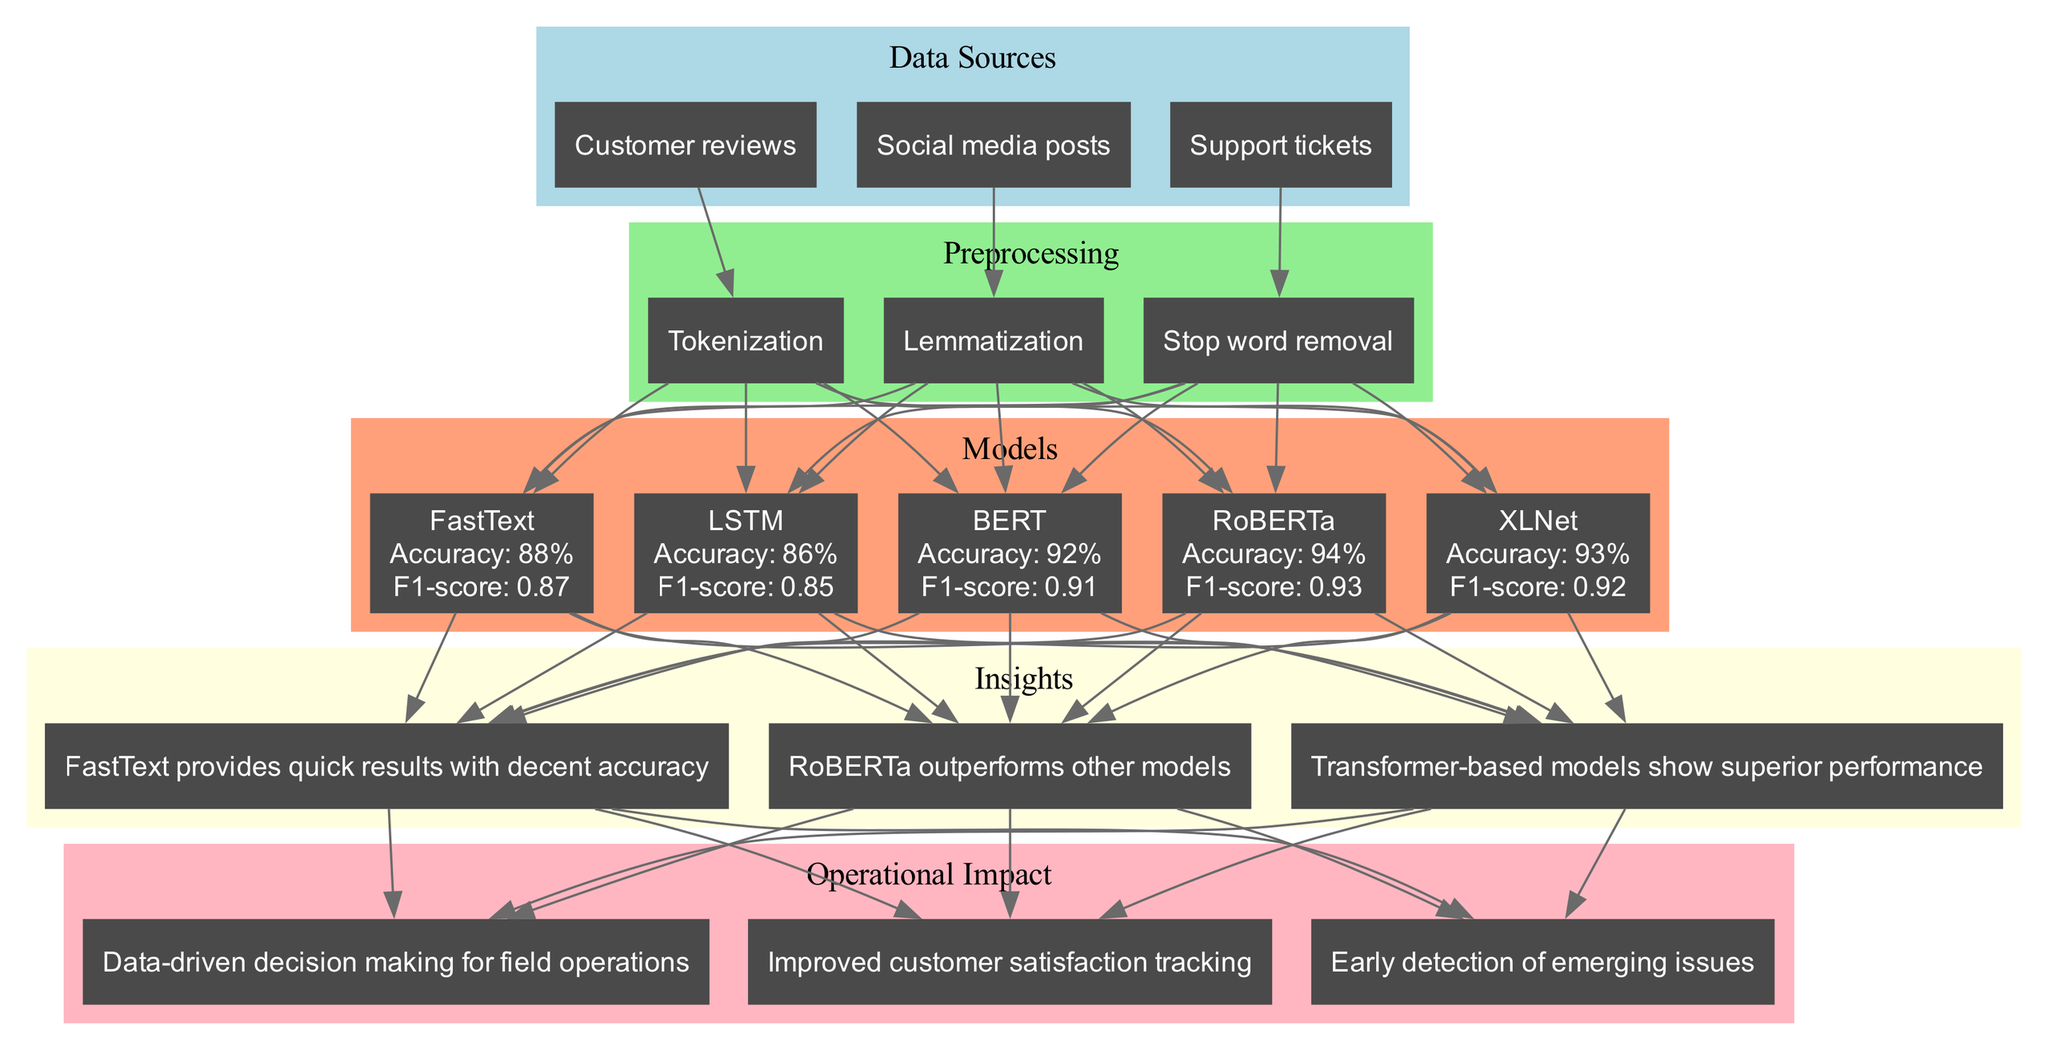What is the accuracy of RoBERTa? The diagram shows the performance results for each model, and specifically for RoBERTa, the accuracy is listed as 94%.
Answer: 94% How many models are displayed in the diagram? By counting the nodes within the "Models" section of the diagram, we can see five models: BERT, RoBERTa, XLNet, FastText, and LSTM.
Answer: 5 Which model has the highest F1-score? By evaluating the F1-scores for each model, RoBERTa has the highest score at 0.93, making it the top performer in this metric.
Answer: 0.93 What preprocessing steps are used in this machine learning analysis? The diagram outlines three preprocessing steps: Tokenization, Lemmatization, and Stop word removal, each represented in the diagram.
Answer: Tokenization, Lemmatization, Stop word removal Which data source is connected to Tokenization? The diagram indicates that "Customer reviews" is directly connected to the Tokenization step, establishing a clear relationship between the source and the preprocessing step.
Answer: Customer reviews What insight is derived from the performance of transformer-based models? The diagram includes an insight that states "Transformer-based models show superior performance," indicating a general observation about the effectiveness of these models in the sentiment analysis task.
Answer: Transformer-based models show superior performance How many insights are mentioned in the diagram? By examining the "Insights" section of the diagram, we can identify three distinct insights listed there.
Answer: 3 What is the operational impact related to improved customer satisfaction tracking? The diagram connects insights to operational impacts, and specifically, improved customer satisfaction tracking is identified as one of the impacts derived from insights in the performance of the models.
Answer: Improved customer satisfaction tracking Which model has the lowest accuracy in the comparison? Upon reviewing the performance results, we can see that LSTM has the lowest accuracy, recorded at 86%, compared to the other models listed.
Answer: 86% 